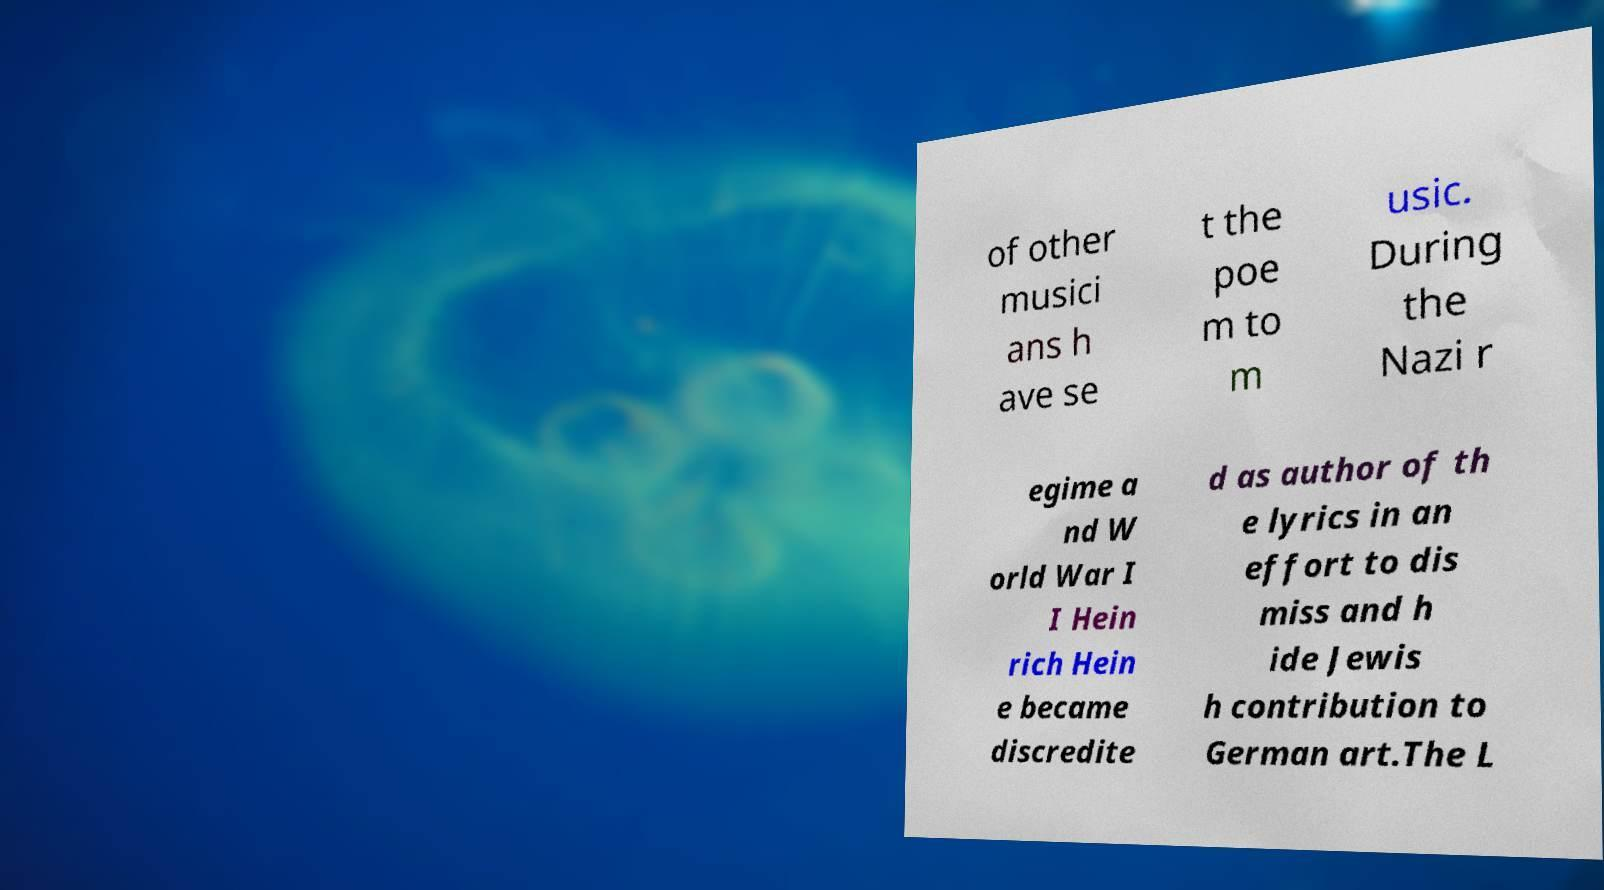For documentation purposes, I need the text within this image transcribed. Could you provide that? of other musici ans h ave se t the poe m to m usic. During the Nazi r egime a nd W orld War I I Hein rich Hein e became discredite d as author of th e lyrics in an effort to dis miss and h ide Jewis h contribution to German art.The L 